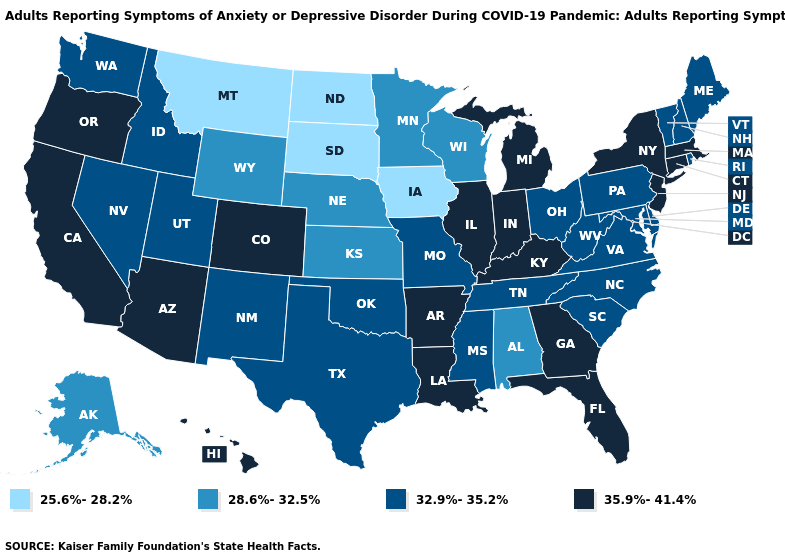Does Rhode Island have the lowest value in the Northeast?
Write a very short answer. Yes. What is the value of Alaska?
Quick response, please. 28.6%-32.5%. What is the value of Michigan?
Be succinct. 35.9%-41.4%. Among the states that border Indiana , which have the highest value?
Concise answer only. Illinois, Kentucky, Michigan. Name the states that have a value in the range 25.6%-28.2%?
Write a very short answer. Iowa, Montana, North Dakota, South Dakota. Name the states that have a value in the range 25.6%-28.2%?
Short answer required. Iowa, Montana, North Dakota, South Dakota. Name the states that have a value in the range 35.9%-41.4%?
Be succinct. Arizona, Arkansas, California, Colorado, Connecticut, Florida, Georgia, Hawaii, Illinois, Indiana, Kentucky, Louisiana, Massachusetts, Michigan, New Jersey, New York, Oregon. What is the value of Washington?
Short answer required. 32.9%-35.2%. What is the lowest value in states that border Utah?
Give a very brief answer. 28.6%-32.5%. How many symbols are there in the legend?
Be succinct. 4. Name the states that have a value in the range 32.9%-35.2%?
Keep it brief. Delaware, Idaho, Maine, Maryland, Mississippi, Missouri, Nevada, New Hampshire, New Mexico, North Carolina, Ohio, Oklahoma, Pennsylvania, Rhode Island, South Carolina, Tennessee, Texas, Utah, Vermont, Virginia, Washington, West Virginia. What is the lowest value in the MidWest?
Quick response, please. 25.6%-28.2%. What is the value of Maryland?
Answer briefly. 32.9%-35.2%. Among the states that border California , does Oregon have the highest value?
Keep it brief. Yes. 